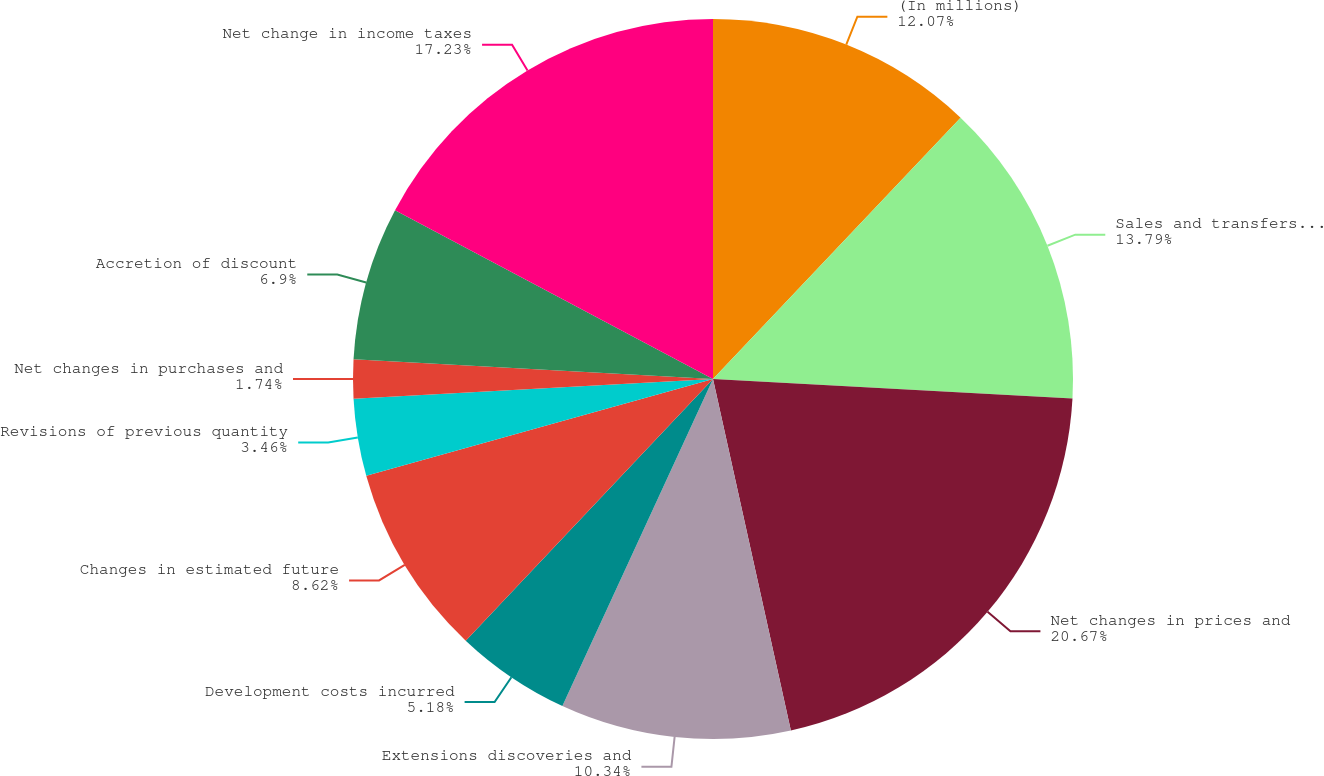Convert chart to OTSL. <chart><loc_0><loc_0><loc_500><loc_500><pie_chart><fcel>(In millions)<fcel>Sales and transfers of oil and<fcel>Net changes in prices and<fcel>Extensions discoveries and<fcel>Development costs incurred<fcel>Changes in estimated future<fcel>Revisions of previous quantity<fcel>Net changes in purchases and<fcel>Accretion of discount<fcel>Net change in income taxes<nl><fcel>12.07%<fcel>13.79%<fcel>20.67%<fcel>10.34%<fcel>5.18%<fcel>8.62%<fcel>3.46%<fcel>1.74%<fcel>6.9%<fcel>17.23%<nl></chart> 